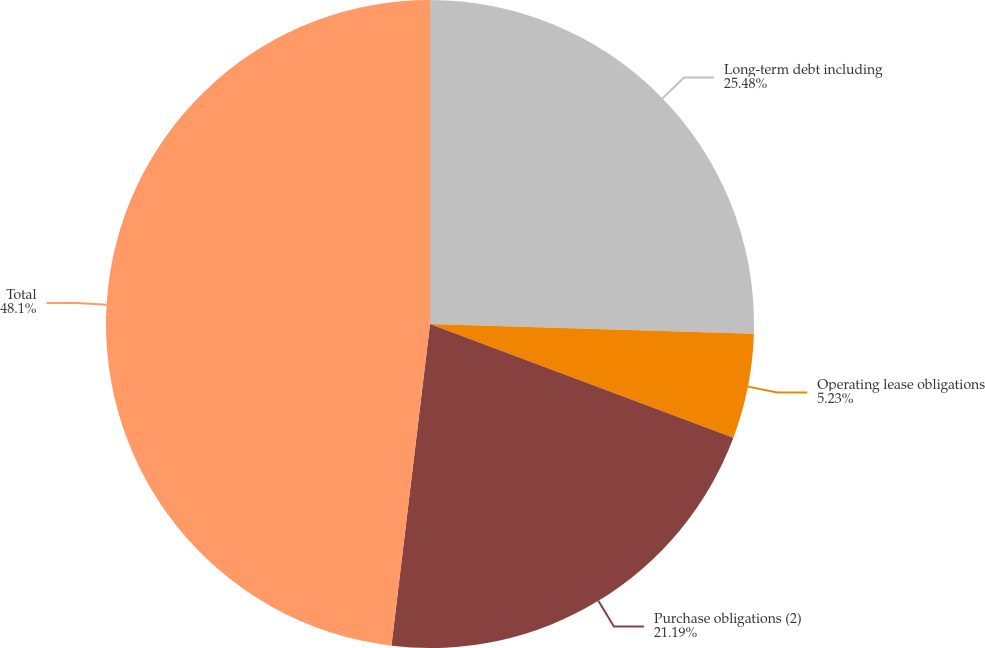<chart> <loc_0><loc_0><loc_500><loc_500><pie_chart><fcel>Long-term debt including<fcel>Operating lease obligations<fcel>Purchase obligations (2)<fcel>Total<nl><fcel>25.48%<fcel>5.23%<fcel>21.19%<fcel>48.1%<nl></chart> 